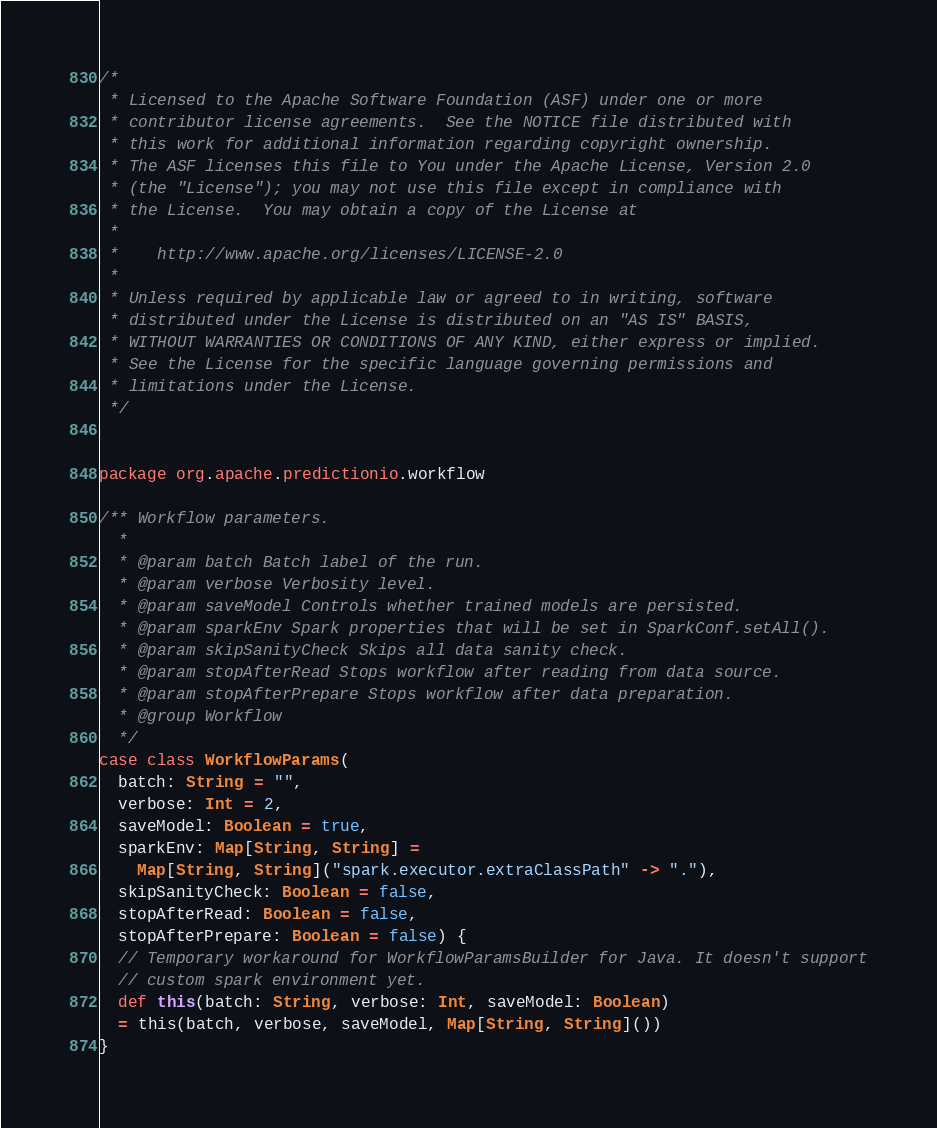<code> <loc_0><loc_0><loc_500><loc_500><_Scala_>/*
 * Licensed to the Apache Software Foundation (ASF) under one or more
 * contributor license agreements.  See the NOTICE file distributed with
 * this work for additional information regarding copyright ownership.
 * The ASF licenses this file to You under the Apache License, Version 2.0
 * (the "License"); you may not use this file except in compliance with
 * the License.  You may obtain a copy of the License at
 *
 *    http://www.apache.org/licenses/LICENSE-2.0
 *
 * Unless required by applicable law or agreed to in writing, software
 * distributed under the License is distributed on an "AS IS" BASIS,
 * WITHOUT WARRANTIES OR CONDITIONS OF ANY KIND, either express or implied.
 * See the License for the specific language governing permissions and
 * limitations under the License.
 */


package org.apache.predictionio.workflow

/** Workflow parameters.
  *
  * @param batch Batch label of the run.
  * @param verbose Verbosity level.
  * @param saveModel Controls whether trained models are persisted.
  * @param sparkEnv Spark properties that will be set in SparkConf.setAll().
  * @param skipSanityCheck Skips all data sanity check.
  * @param stopAfterRead Stops workflow after reading from data source.
  * @param stopAfterPrepare Stops workflow after data preparation.
  * @group Workflow
  */
case class WorkflowParams(
  batch: String = "",
  verbose: Int = 2,
  saveModel: Boolean = true,
  sparkEnv: Map[String, String] =
    Map[String, String]("spark.executor.extraClassPath" -> "."),
  skipSanityCheck: Boolean = false,
  stopAfterRead: Boolean = false,
  stopAfterPrepare: Boolean = false) {
  // Temporary workaround for WorkflowParamsBuilder for Java. It doesn't support
  // custom spark environment yet.
  def this(batch: String, verbose: Int, saveModel: Boolean)
  = this(batch, verbose, saveModel, Map[String, String]())
}
</code> 